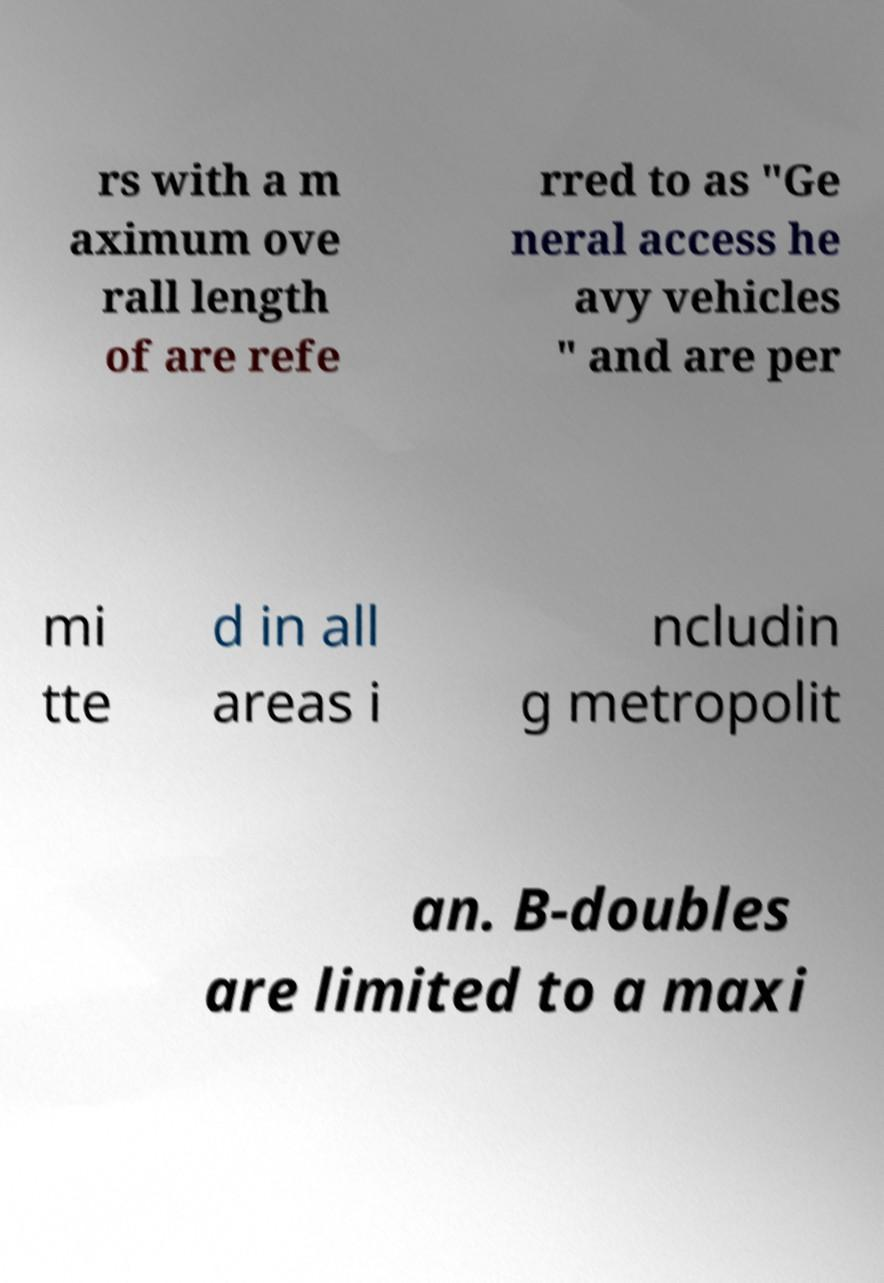Can you read and provide the text displayed in the image?This photo seems to have some interesting text. Can you extract and type it out for me? rs with a m aximum ove rall length of are refe rred to as "Ge neral access he avy vehicles " and are per mi tte d in all areas i ncludin g metropolit an. B-doubles are limited to a maxi 